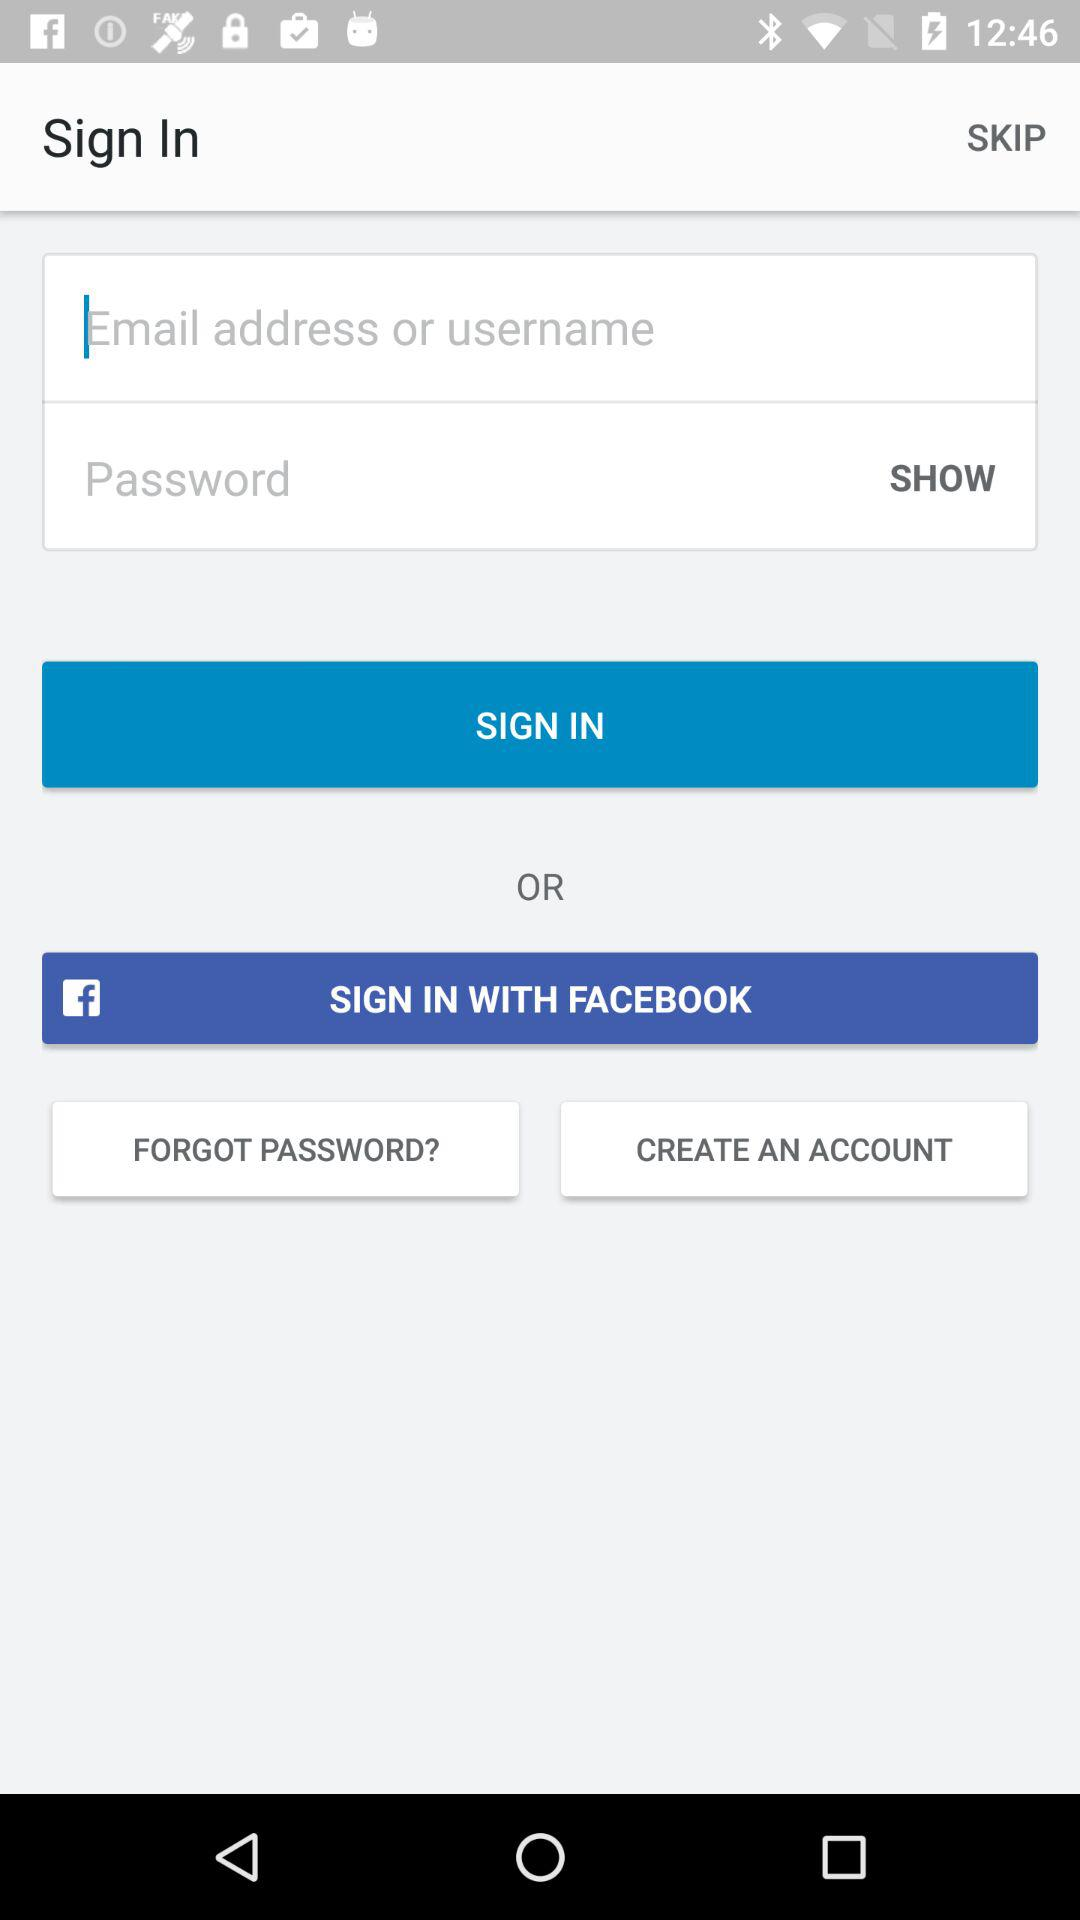Through what application can be used to log in? The application used to log in is Facebook. 